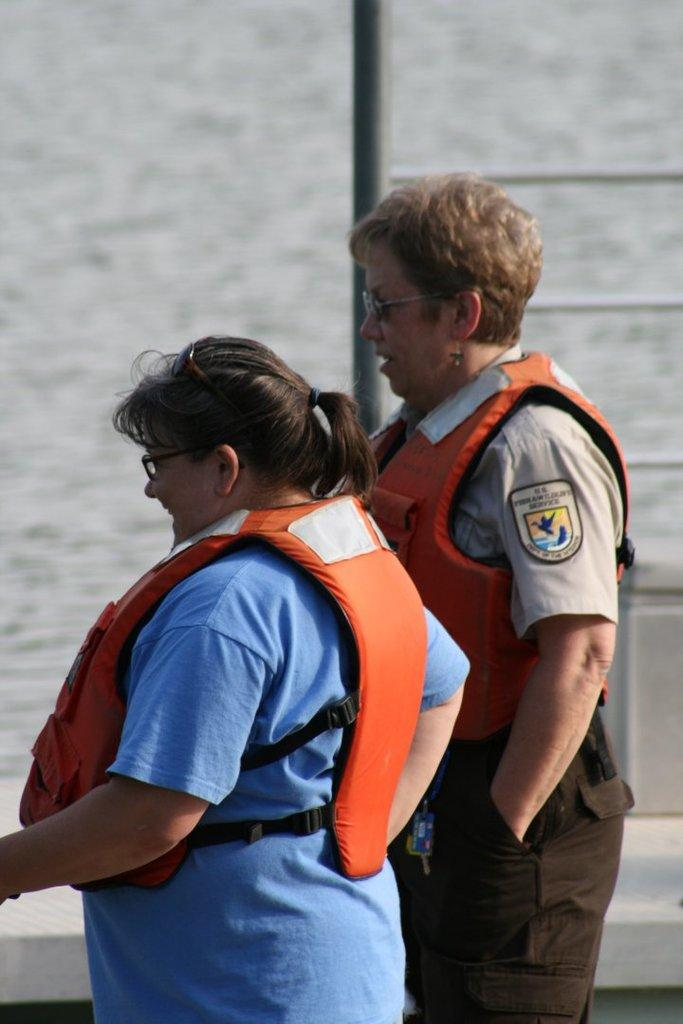How many people are in the image? There are two women in the image. What are the women doing in the image? The women are standing in a boat. Where might the image have been taken? The image is likely taken in the ocean. When was the image taken? The image was taken during the day. What type of dirt can be seen on the women's shoes in the image? There is no dirt visible on the women's shoes in the image. What territory are the women claiming in the image? There is no indication of any territorial claim in the image. 